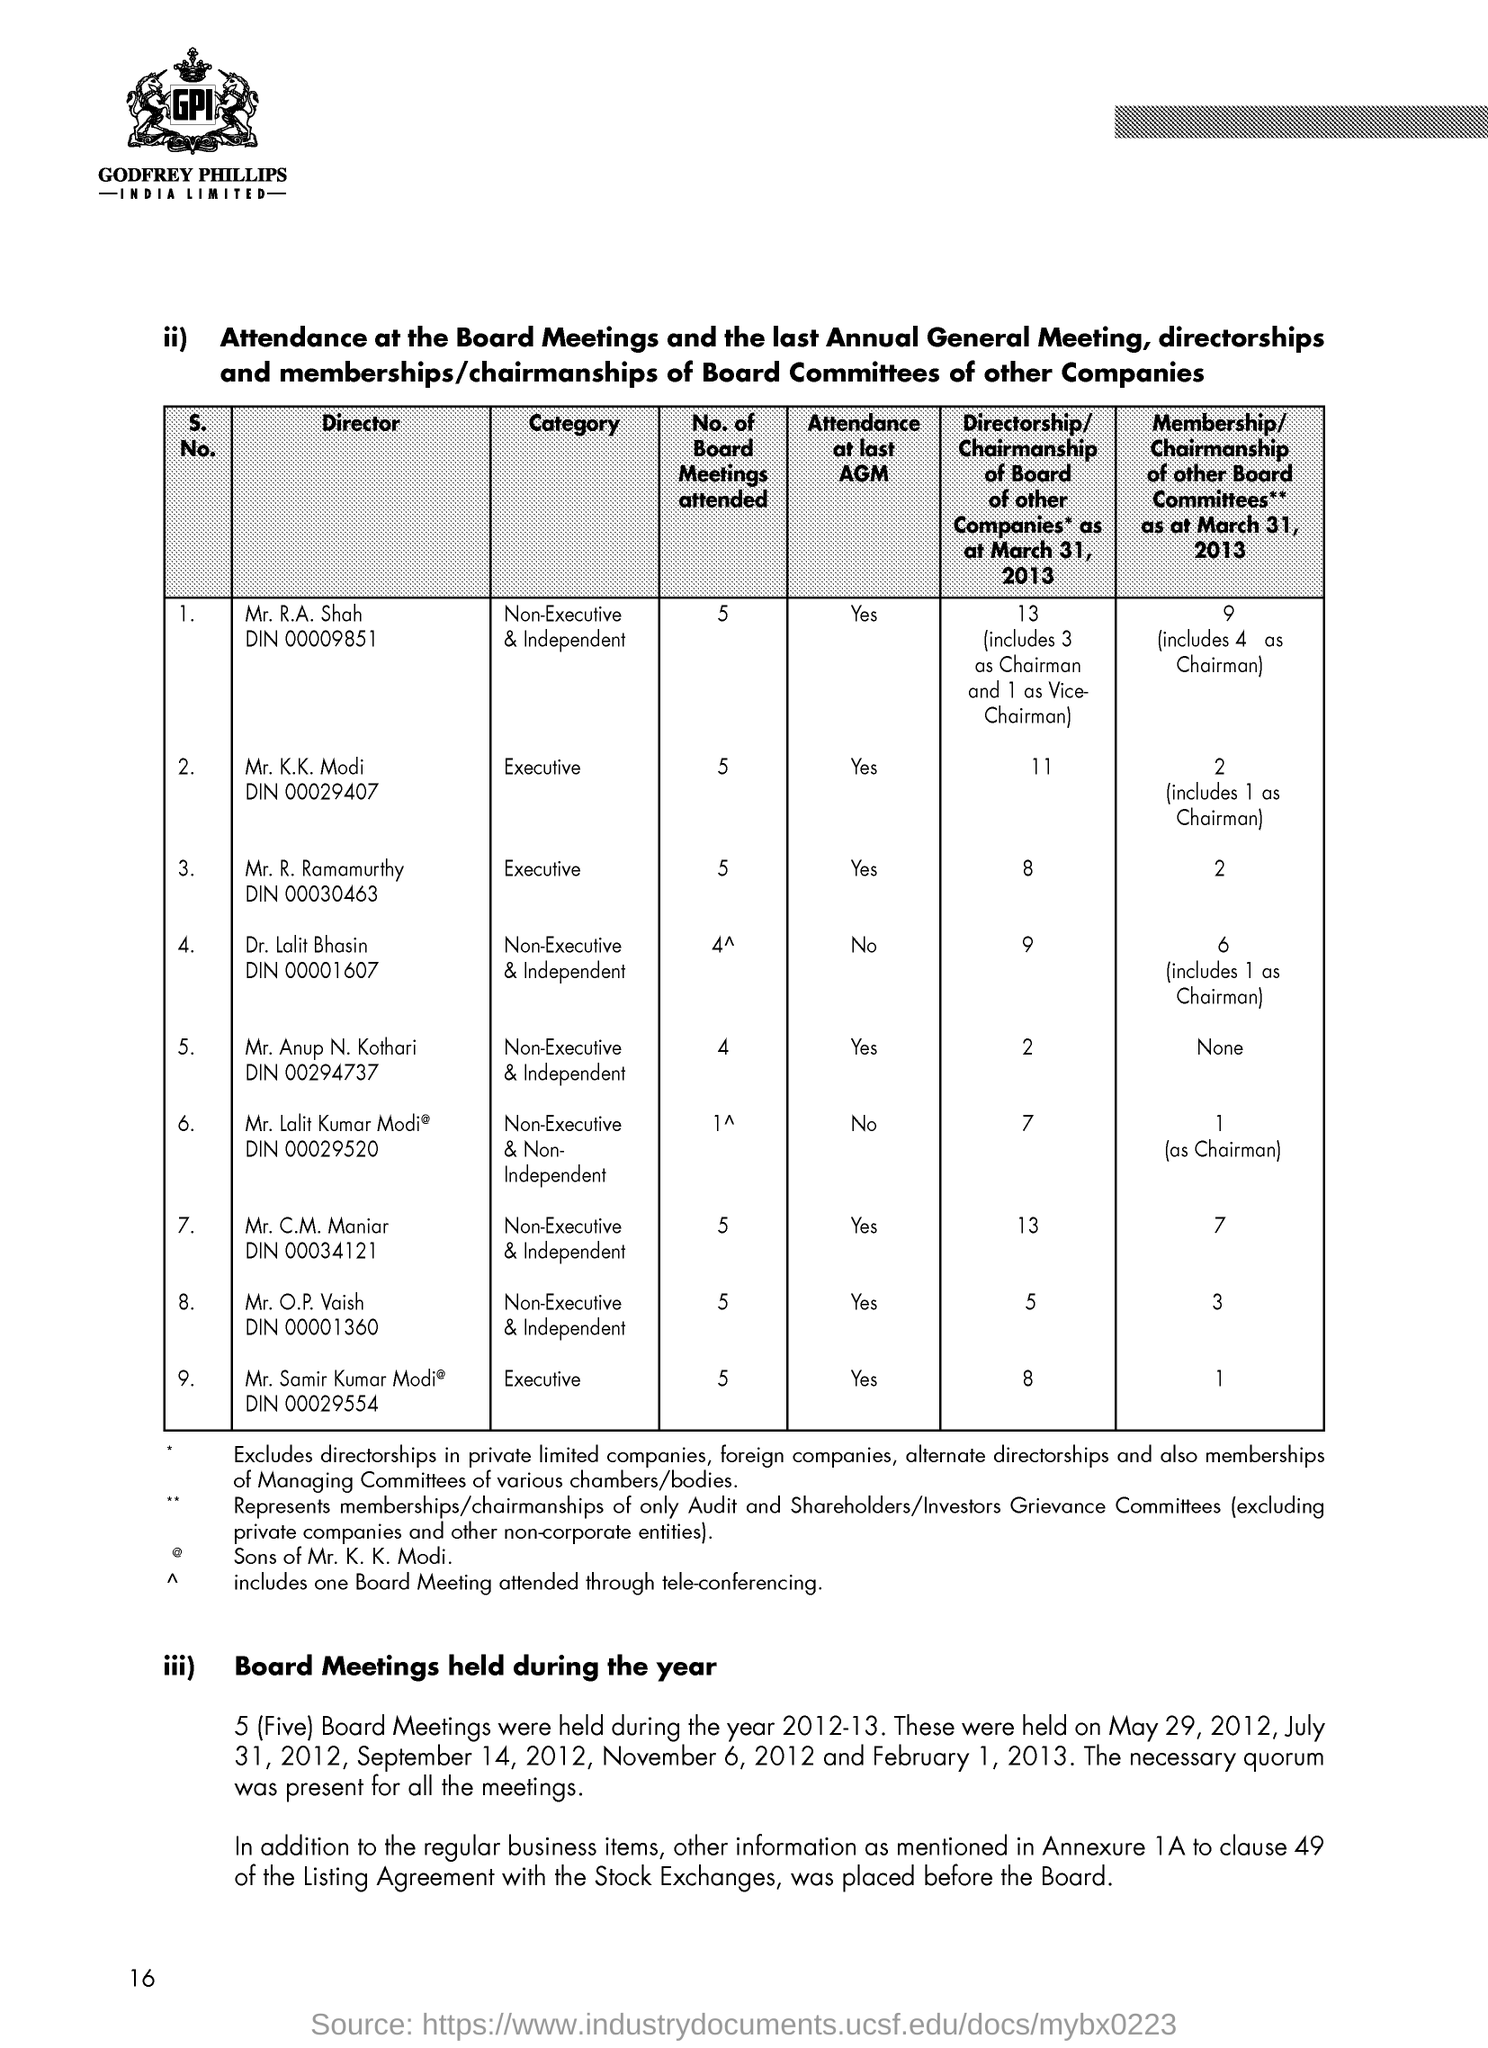What are the No. of Board meetings attented by Mr. R. A. Shah?
Your answer should be very brief. 5. What are the No. of Board meetings attented by Mr. K. K. Modi?
Make the answer very short. 5. What are the No. of Board meetings attented by Mr. R. Ramamurthy?
Make the answer very short. 5. What are the No. of Board meetings attented by Mr. Anup N. Kothari?
Your response must be concise. 4. What are the No. of Board meetings attented by Mr. C. M. Maniar?
Ensure brevity in your answer.  5. What are the No. of Board meetings attented by Mr. O. P. Vaish?
Offer a very short reply. 5. What are the No. of Board meetings attented by Mr. Samir Kumar Modi?
Give a very brief answer. 5. What are the No. of Board meetings attented by Mr. Lalit Kumar Modi?
Your answer should be very brief. 1. What is the Page Number?
Keep it short and to the point. 16. 